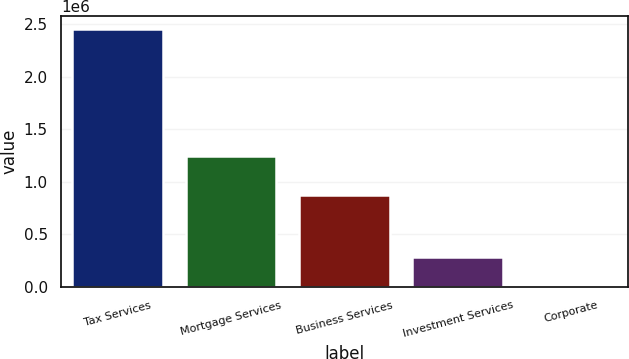<chart> <loc_0><loc_0><loc_500><loc_500><bar_chart><fcel>Tax Services<fcel>Mortgage Services<fcel>Business Services<fcel>Investment Services<fcel>Corporate<nl><fcel>2.45181e+06<fcel>1.24714e+06<fcel>877259<fcel>287955<fcel>8643<nl></chart> 